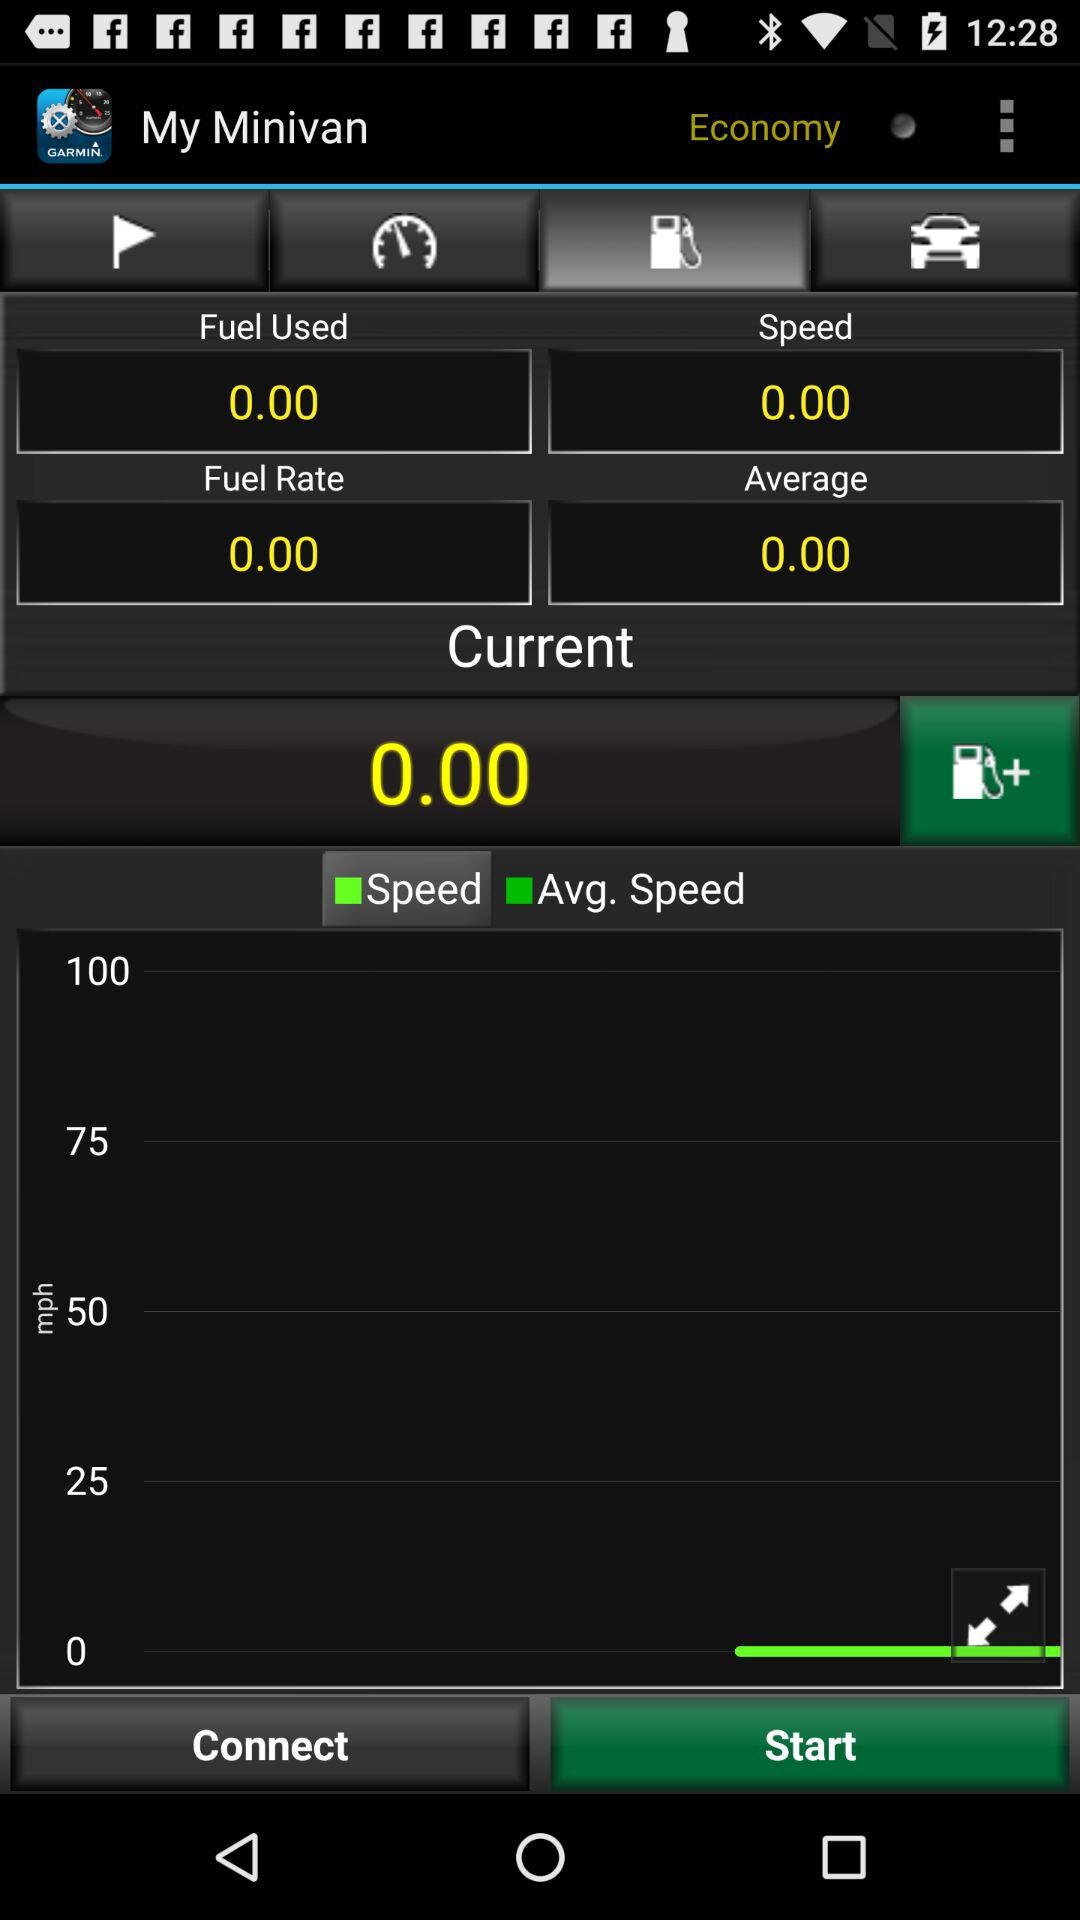How much fuel is used? The amount of fuel used is 0. 